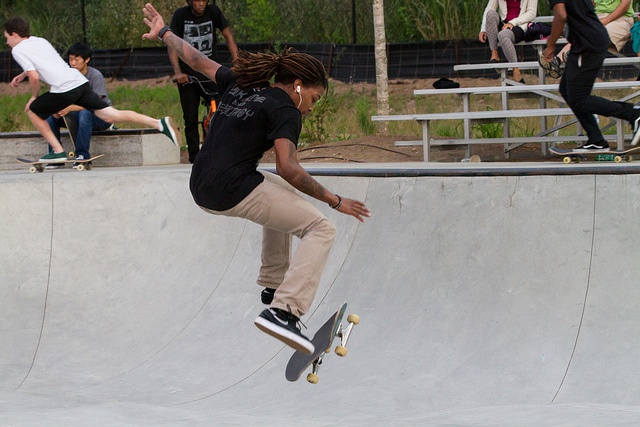Describe the objects in this image and their specific colors. I can see people in black, darkgray, and gray tones, people in black, lavender, brown, and lightpink tones, people in black, gray, darkgray, and maroon tones, people in black, gray, and maroon tones, and people in black, gray, and darkgray tones in this image. 